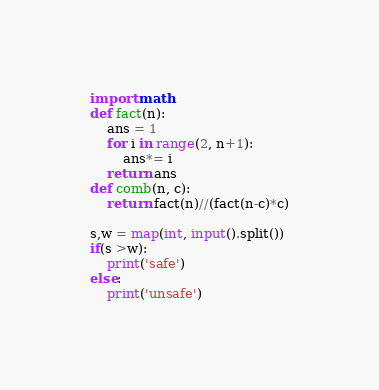<code> <loc_0><loc_0><loc_500><loc_500><_Python_>import math
def fact(n):
    ans = 1
    for i in range(2, n+1):
        ans*= i
    return ans
def comb(n, c):
    return fact(n)//(fact(n-c)*c)

s,w = map(int, input().split())
if(s >w):
    print('safe')
else:
    print('unsafe')
</code> 